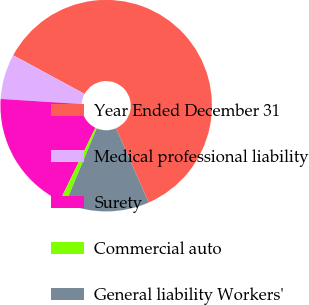<chart> <loc_0><loc_0><loc_500><loc_500><pie_chart><fcel>Year Ended December 31<fcel>Medical professional liability<fcel>Surety<fcel>Commercial auto<fcel>General liability Workers'<nl><fcel>60.52%<fcel>6.89%<fcel>18.81%<fcel>0.93%<fcel>12.85%<nl></chart> 